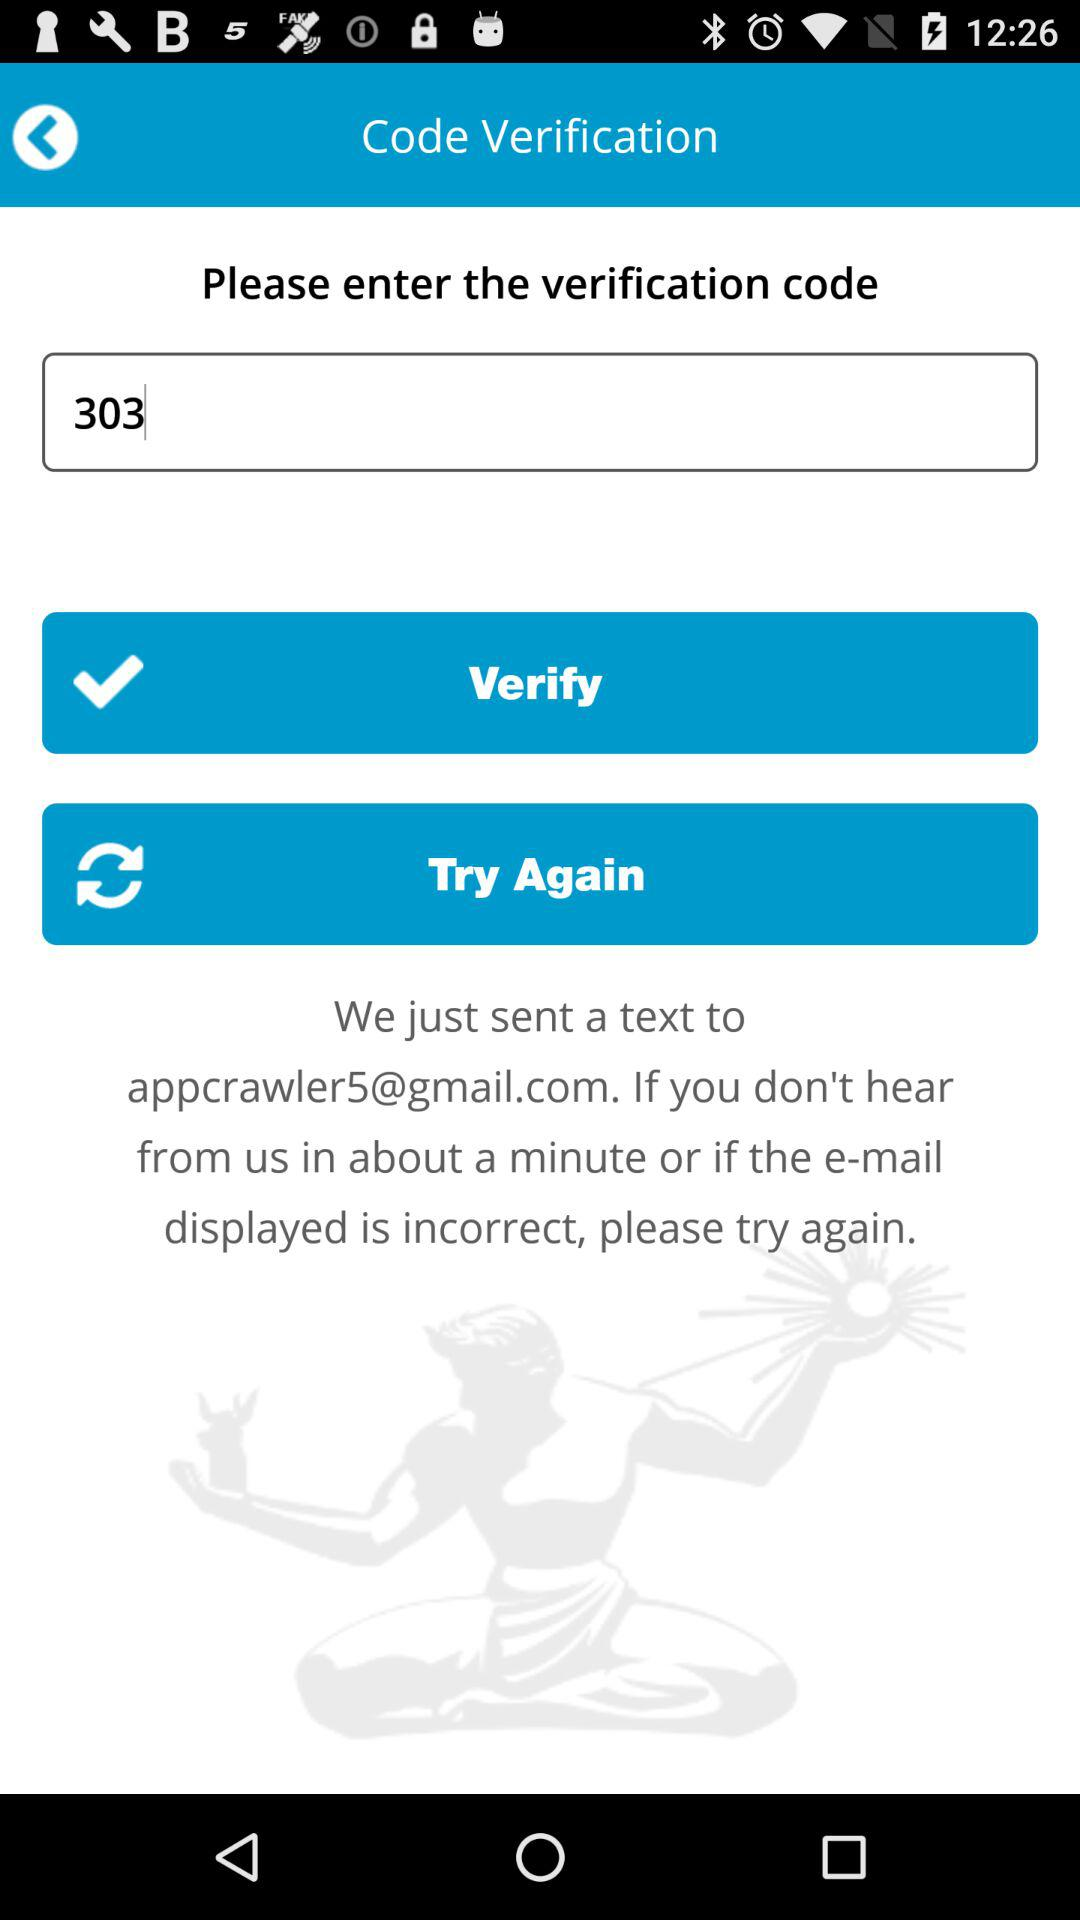Which option is selected?
When the provided information is insufficient, respond with <no answer>. <no answer> 